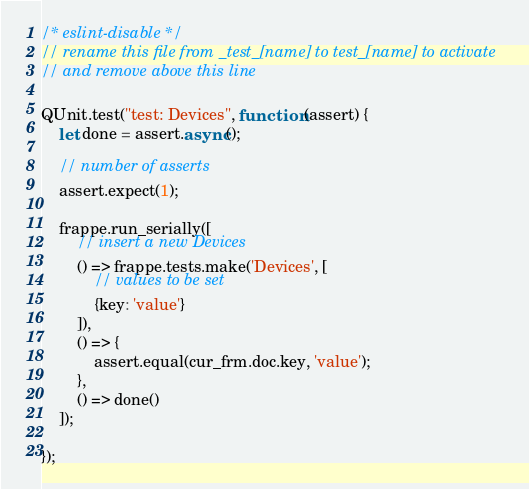Convert code to text. <code><loc_0><loc_0><loc_500><loc_500><_JavaScript_>/* eslint-disable */
// rename this file from _test_[name] to test_[name] to activate
// and remove above this line

QUnit.test("test: Devices", function (assert) {
	let done = assert.async();

	// number of asserts
	assert.expect(1);

	frappe.run_serially([
		// insert a new Devices
		() => frappe.tests.make('Devices', [
			// values to be set
			{key: 'value'}
		]),
		() => {
			assert.equal(cur_frm.doc.key, 'value');
		},
		() => done()
	]);

});
</code> 